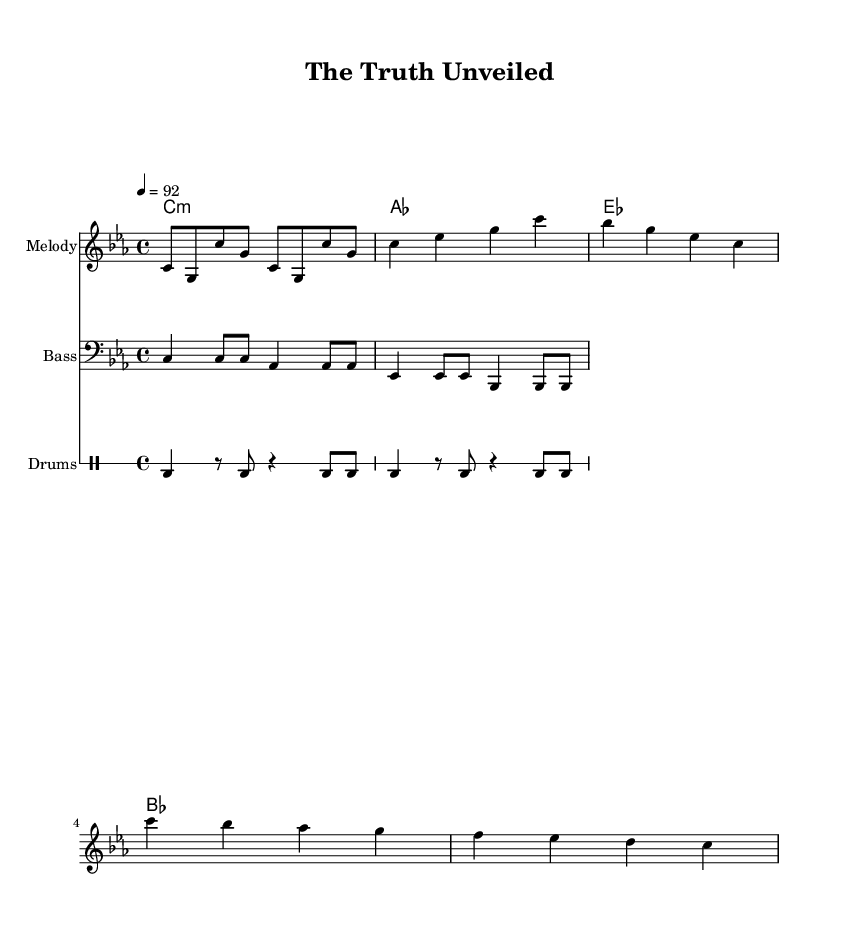What is the key signature of this music? The key signature is C minor, as indicated by the flat symbols found in the music staff for this piece. C minor has three flats: B flat, E flat, and A flat.
Answer: C minor What is the time signature of this piece? The time signature is 4/4, which is often represented by the four beats per measure and is indicated at the beginning of the score. Each measure contains four beats, with the quarter note getting one beat.
Answer: 4/4 What is the tempo of the music? The tempo is set at 92 beats per minute, as defined by the marking provided at the beginning of the score, which guides the performance speed of the piece.
Answer: 92 How many measures are in the verse section? The verse section consists of four measures, as identifiable by the vertical bar lines that separate the measures in the staff. Each measure groups the notes distinctly into sets.
Answer: 4 What type of notes are predominantly used in the melody? The melody predominantly uses eighth notes and quarter notes, as noted in the rhythm representation in the sheet music, which alternates between these note types throughout the piece.
Answer: Eighth and quarter notes What is the instrument for the melody part? The instrument for the melody part is typically a melodic instrument, as indicated by the label "Melody" assigned to this staff in the score. This label denotes the primary focus of this musical line.
Answer: Melody What chord is played in the chorus section? The chord progression during the chorus section includes C, B flat, A flat, and G chords, which create the harmonic foundation that complements the melody and rhythm.
Answer: C, B flat, A flat, G 